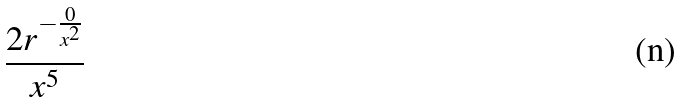Convert formula to latex. <formula><loc_0><loc_0><loc_500><loc_500>\frac { 2 r ^ { - \frac { 0 } { x ^ { 2 } } } } { x ^ { 5 } }</formula> 